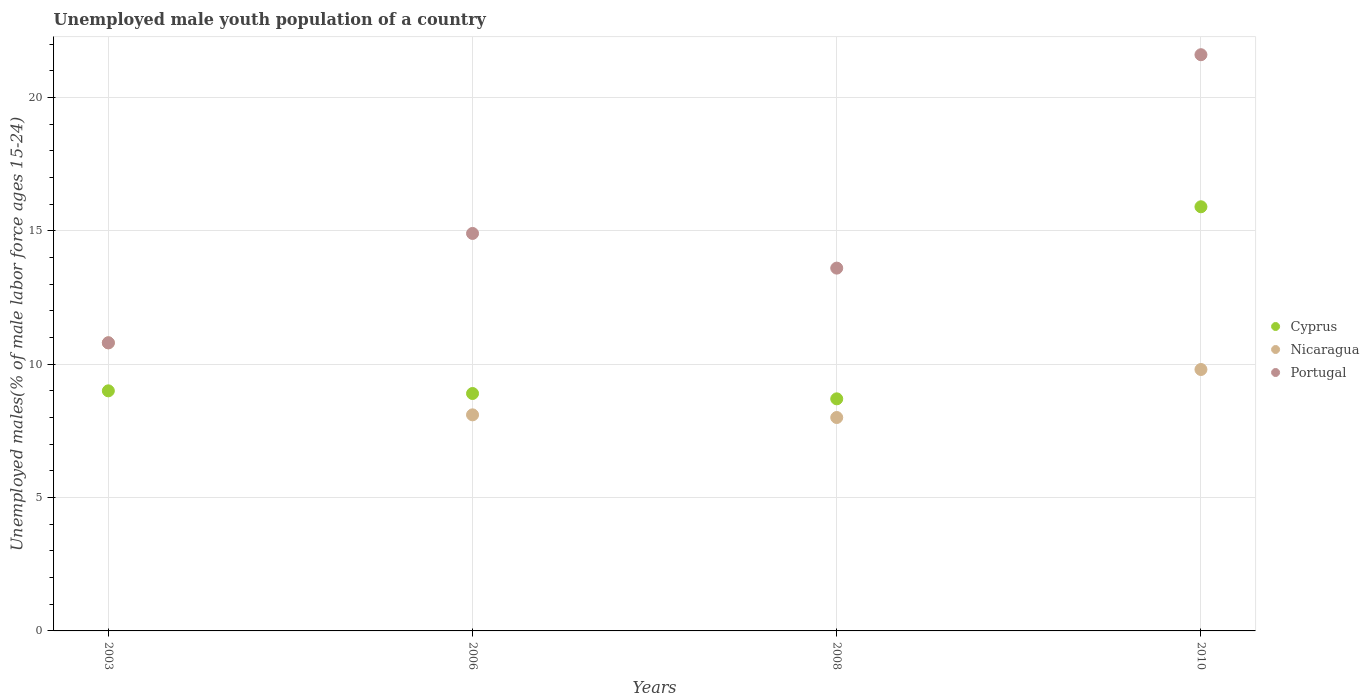Is the number of dotlines equal to the number of legend labels?
Your answer should be compact. Yes. What is the percentage of unemployed male youth population in Portugal in 2006?
Offer a terse response. 14.9. Across all years, what is the maximum percentage of unemployed male youth population in Nicaragua?
Your answer should be very brief. 10.8. In which year was the percentage of unemployed male youth population in Portugal minimum?
Give a very brief answer. 2003. What is the total percentage of unemployed male youth population in Portugal in the graph?
Provide a short and direct response. 60.9. What is the difference between the percentage of unemployed male youth population in Portugal in 2003 and that in 2010?
Your answer should be compact. -10.8. What is the difference between the percentage of unemployed male youth population in Cyprus in 2006 and the percentage of unemployed male youth population in Nicaragua in 2008?
Your response must be concise. 0.9. What is the average percentage of unemployed male youth population in Nicaragua per year?
Keep it short and to the point. 9.18. In the year 2010, what is the difference between the percentage of unemployed male youth population in Portugal and percentage of unemployed male youth population in Nicaragua?
Ensure brevity in your answer.  11.8. In how many years, is the percentage of unemployed male youth population in Cyprus greater than 10 %?
Provide a short and direct response. 1. What is the ratio of the percentage of unemployed male youth population in Portugal in 2003 to that in 2008?
Give a very brief answer. 0.79. Is the percentage of unemployed male youth population in Cyprus in 2003 less than that in 2006?
Make the answer very short. No. What is the difference between the highest and the second highest percentage of unemployed male youth population in Cyprus?
Your response must be concise. 6.9. What is the difference between the highest and the lowest percentage of unemployed male youth population in Cyprus?
Your answer should be very brief. 7.2. In how many years, is the percentage of unemployed male youth population in Nicaragua greater than the average percentage of unemployed male youth population in Nicaragua taken over all years?
Your answer should be compact. 2. Is the sum of the percentage of unemployed male youth population in Cyprus in 2006 and 2010 greater than the maximum percentage of unemployed male youth population in Nicaragua across all years?
Your response must be concise. Yes. Does the percentage of unemployed male youth population in Cyprus monotonically increase over the years?
Offer a very short reply. No. Is the percentage of unemployed male youth population in Portugal strictly greater than the percentage of unemployed male youth population in Nicaragua over the years?
Give a very brief answer. No. How many years are there in the graph?
Your response must be concise. 4. Does the graph contain any zero values?
Give a very brief answer. No. How are the legend labels stacked?
Provide a short and direct response. Vertical. What is the title of the graph?
Give a very brief answer. Unemployed male youth population of a country. Does "Haiti" appear as one of the legend labels in the graph?
Your response must be concise. No. What is the label or title of the Y-axis?
Your answer should be compact. Unemployed males(% of male labor force ages 15-24). What is the Unemployed males(% of male labor force ages 15-24) in Nicaragua in 2003?
Ensure brevity in your answer.  10.8. What is the Unemployed males(% of male labor force ages 15-24) in Portugal in 2003?
Your answer should be compact. 10.8. What is the Unemployed males(% of male labor force ages 15-24) in Cyprus in 2006?
Provide a succinct answer. 8.9. What is the Unemployed males(% of male labor force ages 15-24) in Nicaragua in 2006?
Give a very brief answer. 8.1. What is the Unemployed males(% of male labor force ages 15-24) in Portugal in 2006?
Ensure brevity in your answer.  14.9. What is the Unemployed males(% of male labor force ages 15-24) in Cyprus in 2008?
Provide a succinct answer. 8.7. What is the Unemployed males(% of male labor force ages 15-24) in Nicaragua in 2008?
Provide a succinct answer. 8. What is the Unemployed males(% of male labor force ages 15-24) in Portugal in 2008?
Ensure brevity in your answer.  13.6. What is the Unemployed males(% of male labor force ages 15-24) in Cyprus in 2010?
Your response must be concise. 15.9. What is the Unemployed males(% of male labor force ages 15-24) of Nicaragua in 2010?
Your response must be concise. 9.8. What is the Unemployed males(% of male labor force ages 15-24) in Portugal in 2010?
Give a very brief answer. 21.6. Across all years, what is the maximum Unemployed males(% of male labor force ages 15-24) in Cyprus?
Offer a terse response. 15.9. Across all years, what is the maximum Unemployed males(% of male labor force ages 15-24) in Nicaragua?
Provide a succinct answer. 10.8. Across all years, what is the maximum Unemployed males(% of male labor force ages 15-24) of Portugal?
Your answer should be compact. 21.6. Across all years, what is the minimum Unemployed males(% of male labor force ages 15-24) of Cyprus?
Your answer should be very brief. 8.7. Across all years, what is the minimum Unemployed males(% of male labor force ages 15-24) of Portugal?
Provide a short and direct response. 10.8. What is the total Unemployed males(% of male labor force ages 15-24) in Cyprus in the graph?
Keep it short and to the point. 42.5. What is the total Unemployed males(% of male labor force ages 15-24) of Nicaragua in the graph?
Your response must be concise. 36.7. What is the total Unemployed males(% of male labor force ages 15-24) in Portugal in the graph?
Provide a succinct answer. 60.9. What is the difference between the Unemployed males(% of male labor force ages 15-24) in Nicaragua in 2003 and that in 2006?
Give a very brief answer. 2.7. What is the difference between the Unemployed males(% of male labor force ages 15-24) of Portugal in 2003 and that in 2008?
Your answer should be compact. -2.8. What is the difference between the Unemployed males(% of male labor force ages 15-24) in Cyprus in 2003 and that in 2010?
Keep it short and to the point. -6.9. What is the difference between the Unemployed males(% of male labor force ages 15-24) of Portugal in 2003 and that in 2010?
Offer a terse response. -10.8. What is the difference between the Unemployed males(% of male labor force ages 15-24) of Nicaragua in 2006 and that in 2008?
Keep it short and to the point. 0.1. What is the difference between the Unemployed males(% of male labor force ages 15-24) in Nicaragua in 2006 and that in 2010?
Your response must be concise. -1.7. What is the difference between the Unemployed males(% of male labor force ages 15-24) in Nicaragua in 2008 and that in 2010?
Keep it short and to the point. -1.8. What is the difference between the Unemployed males(% of male labor force ages 15-24) of Cyprus in 2003 and the Unemployed males(% of male labor force ages 15-24) of Portugal in 2006?
Ensure brevity in your answer.  -5.9. What is the difference between the Unemployed males(% of male labor force ages 15-24) in Nicaragua in 2003 and the Unemployed males(% of male labor force ages 15-24) in Portugal in 2006?
Offer a very short reply. -4.1. What is the difference between the Unemployed males(% of male labor force ages 15-24) of Cyprus in 2003 and the Unemployed males(% of male labor force ages 15-24) of Portugal in 2008?
Your answer should be compact. -4.6. What is the difference between the Unemployed males(% of male labor force ages 15-24) in Nicaragua in 2003 and the Unemployed males(% of male labor force ages 15-24) in Portugal in 2010?
Your answer should be very brief. -10.8. What is the difference between the Unemployed males(% of male labor force ages 15-24) of Nicaragua in 2006 and the Unemployed males(% of male labor force ages 15-24) of Portugal in 2008?
Offer a very short reply. -5.5. What is the difference between the Unemployed males(% of male labor force ages 15-24) of Cyprus in 2006 and the Unemployed males(% of male labor force ages 15-24) of Nicaragua in 2010?
Offer a very short reply. -0.9. What is the average Unemployed males(% of male labor force ages 15-24) of Cyprus per year?
Give a very brief answer. 10.62. What is the average Unemployed males(% of male labor force ages 15-24) in Nicaragua per year?
Ensure brevity in your answer.  9.18. What is the average Unemployed males(% of male labor force ages 15-24) of Portugal per year?
Keep it short and to the point. 15.22. In the year 2003, what is the difference between the Unemployed males(% of male labor force ages 15-24) of Nicaragua and Unemployed males(% of male labor force ages 15-24) of Portugal?
Your answer should be very brief. 0. In the year 2006, what is the difference between the Unemployed males(% of male labor force ages 15-24) of Cyprus and Unemployed males(% of male labor force ages 15-24) of Portugal?
Keep it short and to the point. -6. In the year 2006, what is the difference between the Unemployed males(% of male labor force ages 15-24) in Nicaragua and Unemployed males(% of male labor force ages 15-24) in Portugal?
Provide a succinct answer. -6.8. In the year 2008, what is the difference between the Unemployed males(% of male labor force ages 15-24) of Nicaragua and Unemployed males(% of male labor force ages 15-24) of Portugal?
Offer a terse response. -5.6. What is the ratio of the Unemployed males(% of male labor force ages 15-24) in Cyprus in 2003 to that in 2006?
Offer a terse response. 1.01. What is the ratio of the Unemployed males(% of male labor force ages 15-24) in Portugal in 2003 to that in 2006?
Your answer should be very brief. 0.72. What is the ratio of the Unemployed males(% of male labor force ages 15-24) of Cyprus in 2003 to that in 2008?
Offer a very short reply. 1.03. What is the ratio of the Unemployed males(% of male labor force ages 15-24) in Nicaragua in 2003 to that in 2008?
Ensure brevity in your answer.  1.35. What is the ratio of the Unemployed males(% of male labor force ages 15-24) of Portugal in 2003 to that in 2008?
Your response must be concise. 0.79. What is the ratio of the Unemployed males(% of male labor force ages 15-24) of Cyprus in 2003 to that in 2010?
Your answer should be very brief. 0.57. What is the ratio of the Unemployed males(% of male labor force ages 15-24) of Nicaragua in 2003 to that in 2010?
Offer a very short reply. 1.1. What is the ratio of the Unemployed males(% of male labor force ages 15-24) in Portugal in 2003 to that in 2010?
Make the answer very short. 0.5. What is the ratio of the Unemployed males(% of male labor force ages 15-24) of Cyprus in 2006 to that in 2008?
Give a very brief answer. 1.02. What is the ratio of the Unemployed males(% of male labor force ages 15-24) of Nicaragua in 2006 to that in 2008?
Give a very brief answer. 1.01. What is the ratio of the Unemployed males(% of male labor force ages 15-24) in Portugal in 2006 to that in 2008?
Provide a succinct answer. 1.1. What is the ratio of the Unemployed males(% of male labor force ages 15-24) of Cyprus in 2006 to that in 2010?
Give a very brief answer. 0.56. What is the ratio of the Unemployed males(% of male labor force ages 15-24) of Nicaragua in 2006 to that in 2010?
Offer a terse response. 0.83. What is the ratio of the Unemployed males(% of male labor force ages 15-24) of Portugal in 2006 to that in 2010?
Your answer should be compact. 0.69. What is the ratio of the Unemployed males(% of male labor force ages 15-24) in Cyprus in 2008 to that in 2010?
Give a very brief answer. 0.55. What is the ratio of the Unemployed males(% of male labor force ages 15-24) of Nicaragua in 2008 to that in 2010?
Your response must be concise. 0.82. What is the ratio of the Unemployed males(% of male labor force ages 15-24) in Portugal in 2008 to that in 2010?
Offer a very short reply. 0.63. What is the difference between the highest and the second highest Unemployed males(% of male labor force ages 15-24) in Cyprus?
Offer a very short reply. 6.9. What is the difference between the highest and the second highest Unemployed males(% of male labor force ages 15-24) in Nicaragua?
Your answer should be compact. 1. What is the difference between the highest and the second highest Unemployed males(% of male labor force ages 15-24) in Portugal?
Offer a very short reply. 6.7. What is the difference between the highest and the lowest Unemployed males(% of male labor force ages 15-24) of Cyprus?
Provide a succinct answer. 7.2. What is the difference between the highest and the lowest Unemployed males(% of male labor force ages 15-24) of Nicaragua?
Keep it short and to the point. 2.8. 